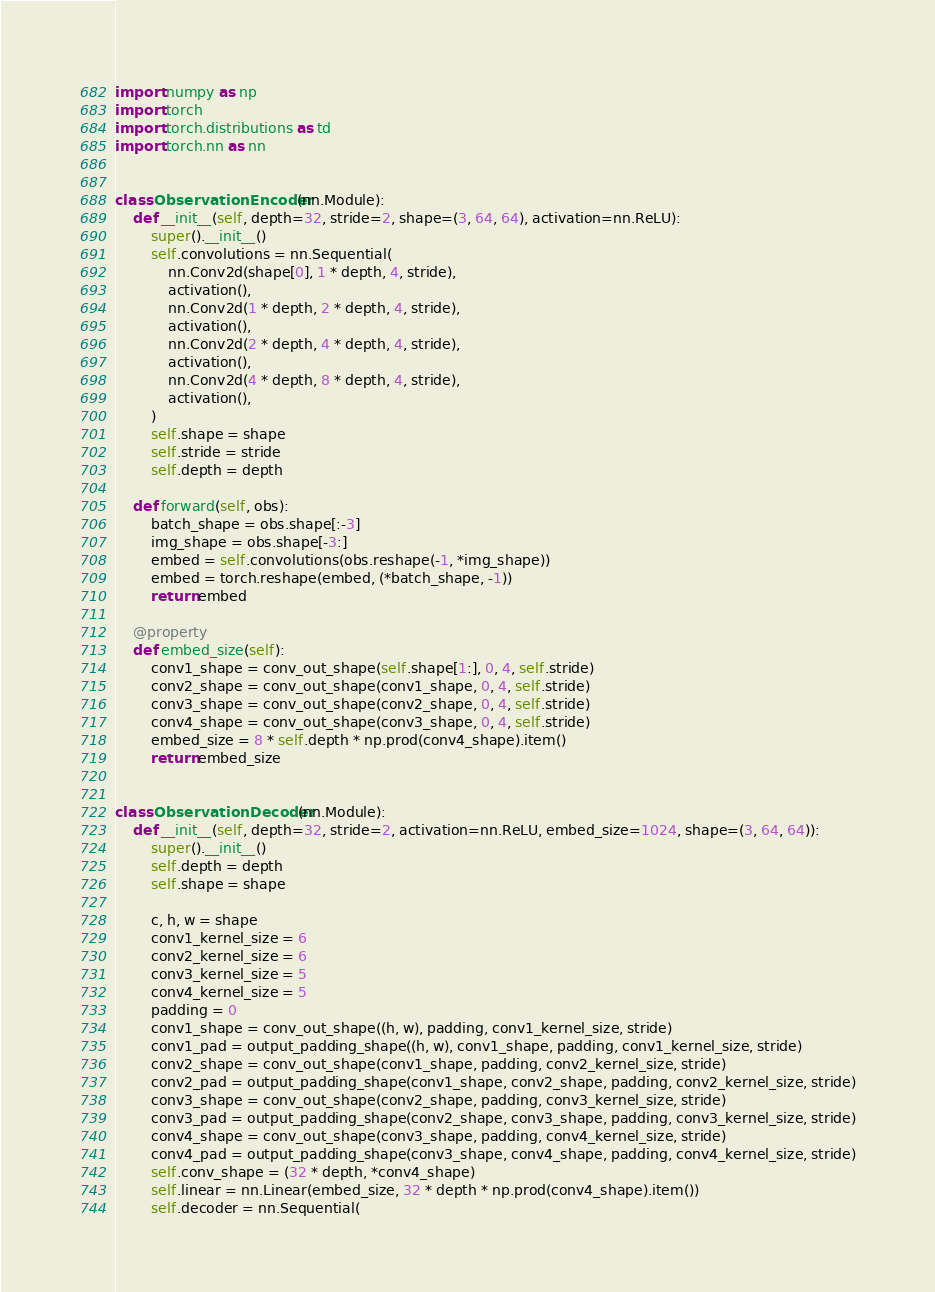<code> <loc_0><loc_0><loc_500><loc_500><_Python_>import numpy as np
import torch
import torch.distributions as td
import torch.nn as nn


class ObservationEncoder(nn.Module):
    def __init__(self, depth=32, stride=2, shape=(3, 64, 64), activation=nn.ReLU):
        super().__init__()
        self.convolutions = nn.Sequential(
            nn.Conv2d(shape[0], 1 * depth, 4, stride),
            activation(),
            nn.Conv2d(1 * depth, 2 * depth, 4, stride),
            activation(),
            nn.Conv2d(2 * depth, 4 * depth, 4, stride),
            activation(),
            nn.Conv2d(4 * depth, 8 * depth, 4, stride),
            activation(),
        )
        self.shape = shape
        self.stride = stride
        self.depth = depth

    def forward(self, obs):
        batch_shape = obs.shape[:-3]
        img_shape = obs.shape[-3:]
        embed = self.convolutions(obs.reshape(-1, *img_shape))
        embed = torch.reshape(embed, (*batch_shape, -1))
        return embed

    @property
    def embed_size(self):
        conv1_shape = conv_out_shape(self.shape[1:], 0, 4, self.stride)
        conv2_shape = conv_out_shape(conv1_shape, 0, 4, self.stride)
        conv3_shape = conv_out_shape(conv2_shape, 0, 4, self.stride)
        conv4_shape = conv_out_shape(conv3_shape, 0, 4, self.stride)
        embed_size = 8 * self.depth * np.prod(conv4_shape).item()
        return embed_size


class ObservationDecoder(nn.Module):
    def __init__(self, depth=32, stride=2, activation=nn.ReLU, embed_size=1024, shape=(3, 64, 64)):
        super().__init__()
        self.depth = depth
        self.shape = shape

        c, h, w = shape
        conv1_kernel_size = 6
        conv2_kernel_size = 6
        conv3_kernel_size = 5
        conv4_kernel_size = 5
        padding = 0
        conv1_shape = conv_out_shape((h, w), padding, conv1_kernel_size, stride)
        conv1_pad = output_padding_shape((h, w), conv1_shape, padding, conv1_kernel_size, stride)
        conv2_shape = conv_out_shape(conv1_shape, padding, conv2_kernel_size, stride)
        conv2_pad = output_padding_shape(conv1_shape, conv2_shape, padding, conv2_kernel_size, stride)
        conv3_shape = conv_out_shape(conv2_shape, padding, conv3_kernel_size, stride)
        conv3_pad = output_padding_shape(conv2_shape, conv3_shape, padding, conv3_kernel_size, stride)
        conv4_shape = conv_out_shape(conv3_shape, padding, conv4_kernel_size, stride)
        conv4_pad = output_padding_shape(conv3_shape, conv4_shape, padding, conv4_kernel_size, stride)
        self.conv_shape = (32 * depth, *conv4_shape)
        self.linear = nn.Linear(embed_size, 32 * depth * np.prod(conv4_shape).item())
        self.decoder = nn.Sequential(</code> 